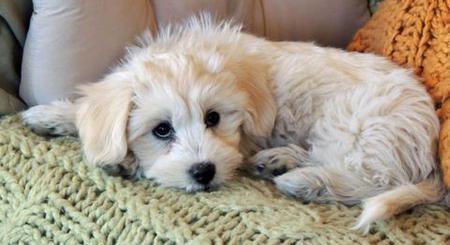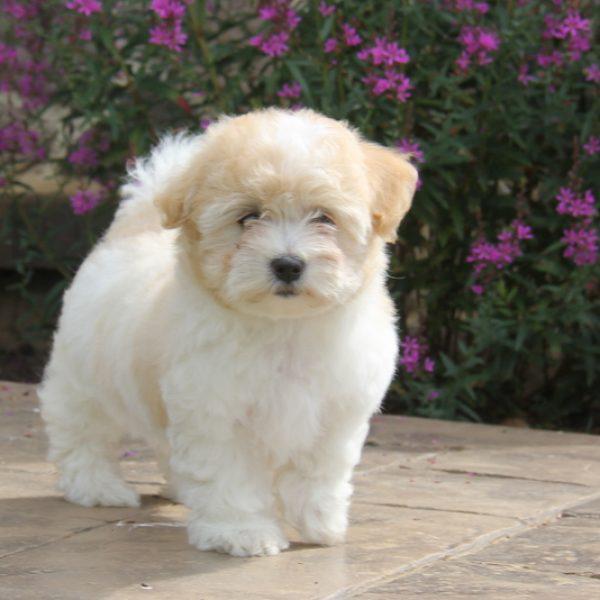The first image is the image on the left, the second image is the image on the right. Evaluate the accuracy of this statement regarding the images: "Each image contains exactly one dog, and all dogs are white and posed outdoors.". Is it true? Answer yes or no. No. The first image is the image on the left, the second image is the image on the right. For the images shown, is this caption "The dog in the image on the right is standing on the grass." true? Answer yes or no. No. 